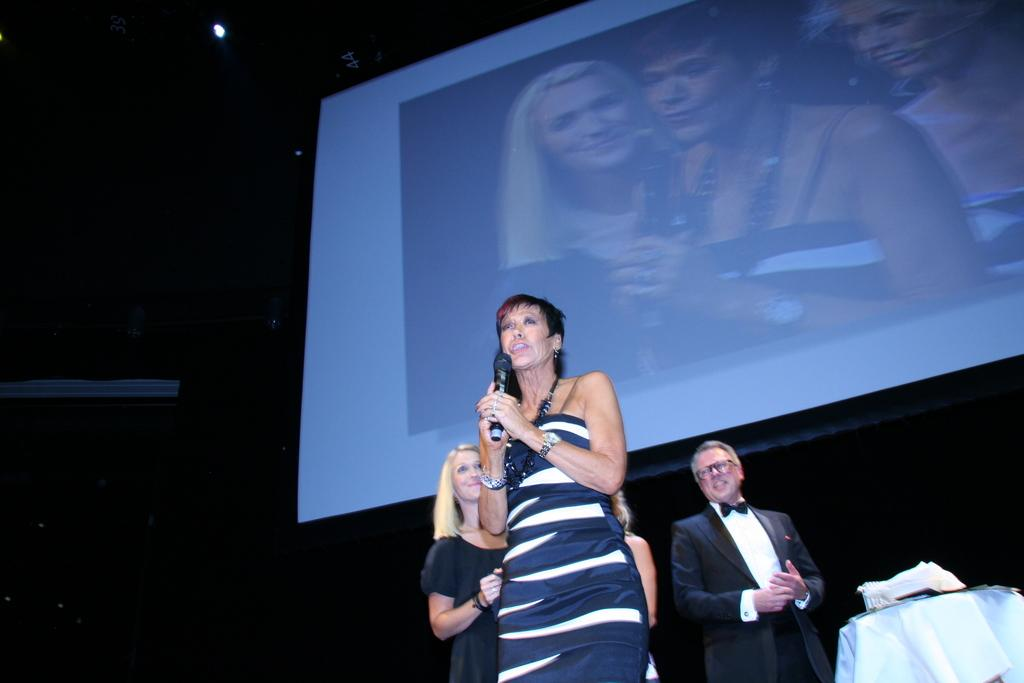What is the woman in the image doing? The woman is standing and speaking into a microphone in the image. What is the man in the image wearing? The man is standing and wearing a coat and shirt in the image. What is located in the middle of the image? There is a projector screen in the middle of the image. What type of bottle is being passed around by the feet in the image? There is no bottle or feet present in the image. 